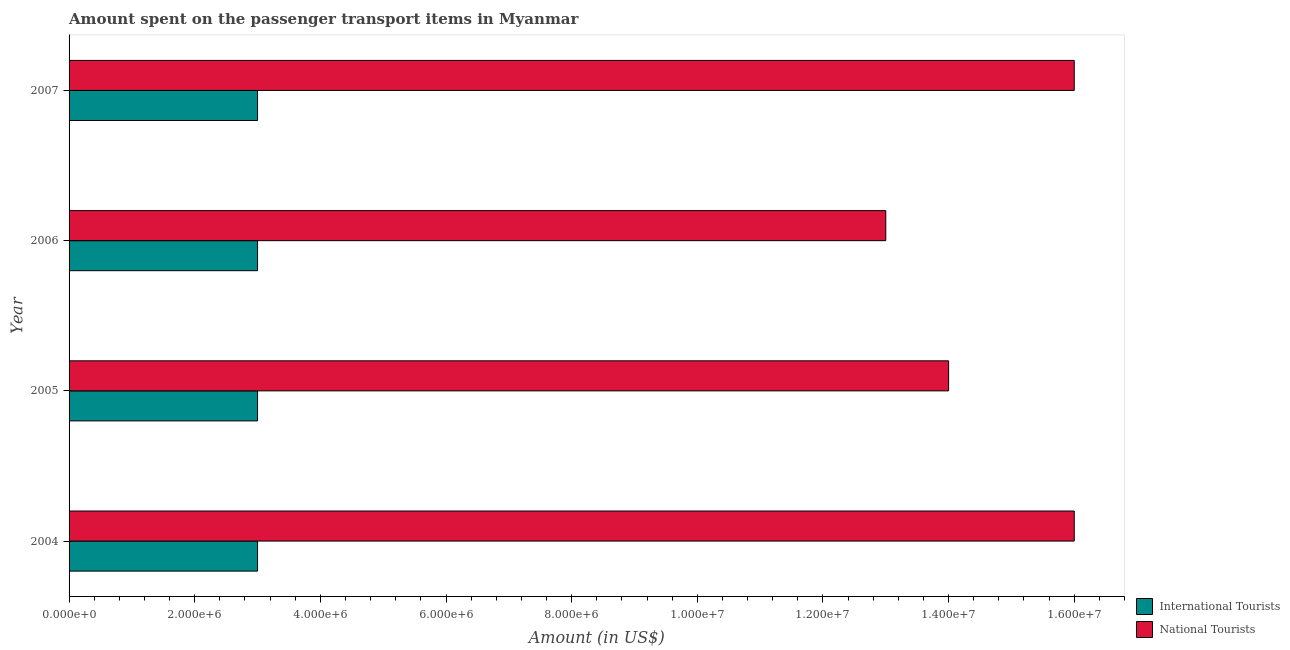What is the label of the 1st group of bars from the top?
Your response must be concise. 2007. In how many cases, is the number of bars for a given year not equal to the number of legend labels?
Give a very brief answer. 0. What is the amount spent on transport items of national tourists in 2005?
Give a very brief answer. 1.40e+07. Across all years, what is the maximum amount spent on transport items of national tourists?
Keep it short and to the point. 1.60e+07. Across all years, what is the minimum amount spent on transport items of national tourists?
Your response must be concise. 1.30e+07. What is the total amount spent on transport items of national tourists in the graph?
Keep it short and to the point. 5.90e+07. What is the difference between the amount spent on transport items of national tourists in 2005 and the amount spent on transport items of international tourists in 2007?
Make the answer very short. 1.10e+07. What is the average amount spent on transport items of national tourists per year?
Provide a short and direct response. 1.48e+07. In the year 2005, what is the difference between the amount spent on transport items of national tourists and amount spent on transport items of international tourists?
Offer a terse response. 1.10e+07. Is the difference between the amount spent on transport items of national tourists in 2004 and 2007 greater than the difference between the amount spent on transport items of international tourists in 2004 and 2007?
Your response must be concise. No. What is the difference between the highest and the second highest amount spent on transport items of international tourists?
Ensure brevity in your answer.  0. Is the sum of the amount spent on transport items of national tourists in 2004 and 2006 greater than the maximum amount spent on transport items of international tourists across all years?
Your answer should be very brief. Yes. What does the 2nd bar from the top in 2005 represents?
Your answer should be compact. International Tourists. What does the 1st bar from the bottom in 2005 represents?
Offer a very short reply. International Tourists. How many bars are there?
Ensure brevity in your answer.  8. Are all the bars in the graph horizontal?
Your answer should be compact. Yes. Does the graph contain any zero values?
Provide a short and direct response. No. Does the graph contain grids?
Provide a short and direct response. No. How are the legend labels stacked?
Offer a very short reply. Vertical. What is the title of the graph?
Your answer should be very brief. Amount spent on the passenger transport items in Myanmar. Does "Register a business" appear as one of the legend labels in the graph?
Give a very brief answer. No. What is the label or title of the Y-axis?
Provide a short and direct response. Year. What is the Amount (in US$) in International Tourists in 2004?
Make the answer very short. 3.00e+06. What is the Amount (in US$) of National Tourists in 2004?
Ensure brevity in your answer.  1.60e+07. What is the Amount (in US$) in National Tourists in 2005?
Provide a short and direct response. 1.40e+07. What is the Amount (in US$) in International Tourists in 2006?
Your answer should be compact. 3.00e+06. What is the Amount (in US$) of National Tourists in 2006?
Give a very brief answer. 1.30e+07. What is the Amount (in US$) in International Tourists in 2007?
Your answer should be compact. 3.00e+06. What is the Amount (in US$) in National Tourists in 2007?
Make the answer very short. 1.60e+07. Across all years, what is the maximum Amount (in US$) in International Tourists?
Your answer should be compact. 3.00e+06. Across all years, what is the maximum Amount (in US$) in National Tourists?
Your answer should be compact. 1.60e+07. Across all years, what is the minimum Amount (in US$) of National Tourists?
Provide a succinct answer. 1.30e+07. What is the total Amount (in US$) of National Tourists in the graph?
Provide a succinct answer. 5.90e+07. What is the difference between the Amount (in US$) of International Tourists in 2004 and that in 2006?
Offer a terse response. 0. What is the difference between the Amount (in US$) in National Tourists in 2004 and that in 2007?
Give a very brief answer. 0. What is the difference between the Amount (in US$) in International Tourists in 2005 and that in 2006?
Provide a short and direct response. 0. What is the difference between the Amount (in US$) of National Tourists in 2005 and that in 2006?
Offer a very short reply. 1.00e+06. What is the difference between the Amount (in US$) in International Tourists in 2005 and that in 2007?
Give a very brief answer. 0. What is the difference between the Amount (in US$) of International Tourists in 2006 and that in 2007?
Your answer should be compact. 0. What is the difference between the Amount (in US$) of National Tourists in 2006 and that in 2007?
Offer a terse response. -3.00e+06. What is the difference between the Amount (in US$) in International Tourists in 2004 and the Amount (in US$) in National Tourists in 2005?
Your answer should be very brief. -1.10e+07. What is the difference between the Amount (in US$) of International Tourists in 2004 and the Amount (in US$) of National Tourists in 2006?
Offer a very short reply. -1.00e+07. What is the difference between the Amount (in US$) of International Tourists in 2004 and the Amount (in US$) of National Tourists in 2007?
Provide a short and direct response. -1.30e+07. What is the difference between the Amount (in US$) in International Tourists in 2005 and the Amount (in US$) in National Tourists in 2006?
Provide a succinct answer. -1.00e+07. What is the difference between the Amount (in US$) of International Tourists in 2005 and the Amount (in US$) of National Tourists in 2007?
Ensure brevity in your answer.  -1.30e+07. What is the difference between the Amount (in US$) of International Tourists in 2006 and the Amount (in US$) of National Tourists in 2007?
Make the answer very short. -1.30e+07. What is the average Amount (in US$) of International Tourists per year?
Offer a terse response. 3.00e+06. What is the average Amount (in US$) in National Tourists per year?
Offer a very short reply. 1.48e+07. In the year 2004, what is the difference between the Amount (in US$) of International Tourists and Amount (in US$) of National Tourists?
Your answer should be very brief. -1.30e+07. In the year 2005, what is the difference between the Amount (in US$) of International Tourists and Amount (in US$) of National Tourists?
Offer a very short reply. -1.10e+07. In the year 2006, what is the difference between the Amount (in US$) in International Tourists and Amount (in US$) in National Tourists?
Your answer should be very brief. -1.00e+07. In the year 2007, what is the difference between the Amount (in US$) in International Tourists and Amount (in US$) in National Tourists?
Offer a very short reply. -1.30e+07. What is the ratio of the Amount (in US$) of International Tourists in 2004 to that in 2005?
Your response must be concise. 1. What is the ratio of the Amount (in US$) of National Tourists in 2004 to that in 2005?
Provide a short and direct response. 1.14. What is the ratio of the Amount (in US$) of National Tourists in 2004 to that in 2006?
Your response must be concise. 1.23. What is the ratio of the Amount (in US$) of International Tourists in 2004 to that in 2007?
Your answer should be very brief. 1. What is the ratio of the Amount (in US$) in National Tourists in 2004 to that in 2007?
Provide a succinct answer. 1. What is the ratio of the Amount (in US$) in International Tourists in 2005 to that in 2006?
Provide a succinct answer. 1. What is the ratio of the Amount (in US$) in International Tourists in 2005 to that in 2007?
Provide a short and direct response. 1. What is the ratio of the Amount (in US$) in National Tourists in 2006 to that in 2007?
Your answer should be compact. 0.81. What is the difference between the highest and the second highest Amount (in US$) in National Tourists?
Offer a very short reply. 0. What is the difference between the highest and the lowest Amount (in US$) of National Tourists?
Offer a terse response. 3.00e+06. 